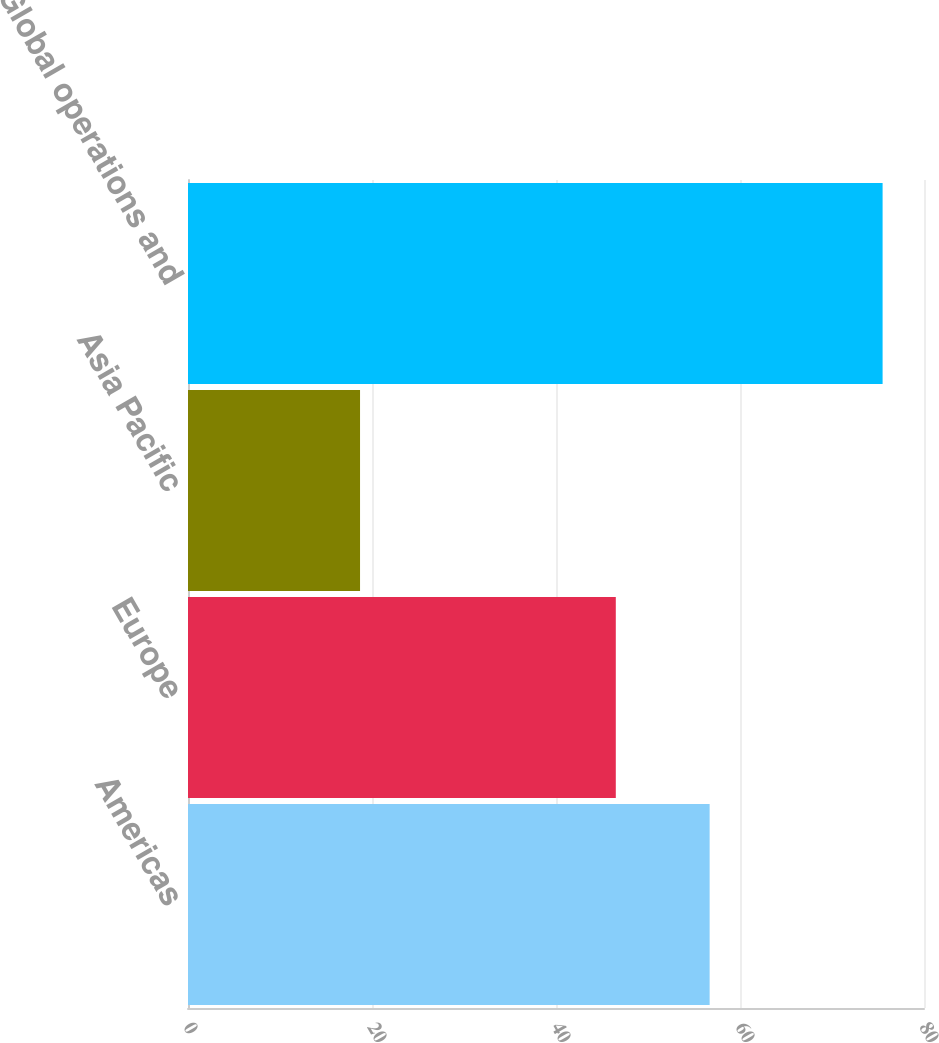Convert chart to OTSL. <chart><loc_0><loc_0><loc_500><loc_500><bar_chart><fcel>Americas<fcel>Europe<fcel>Asia Pacific<fcel>Global operations and<nl><fcel>56.7<fcel>46.5<fcel>18.7<fcel>75.5<nl></chart> 